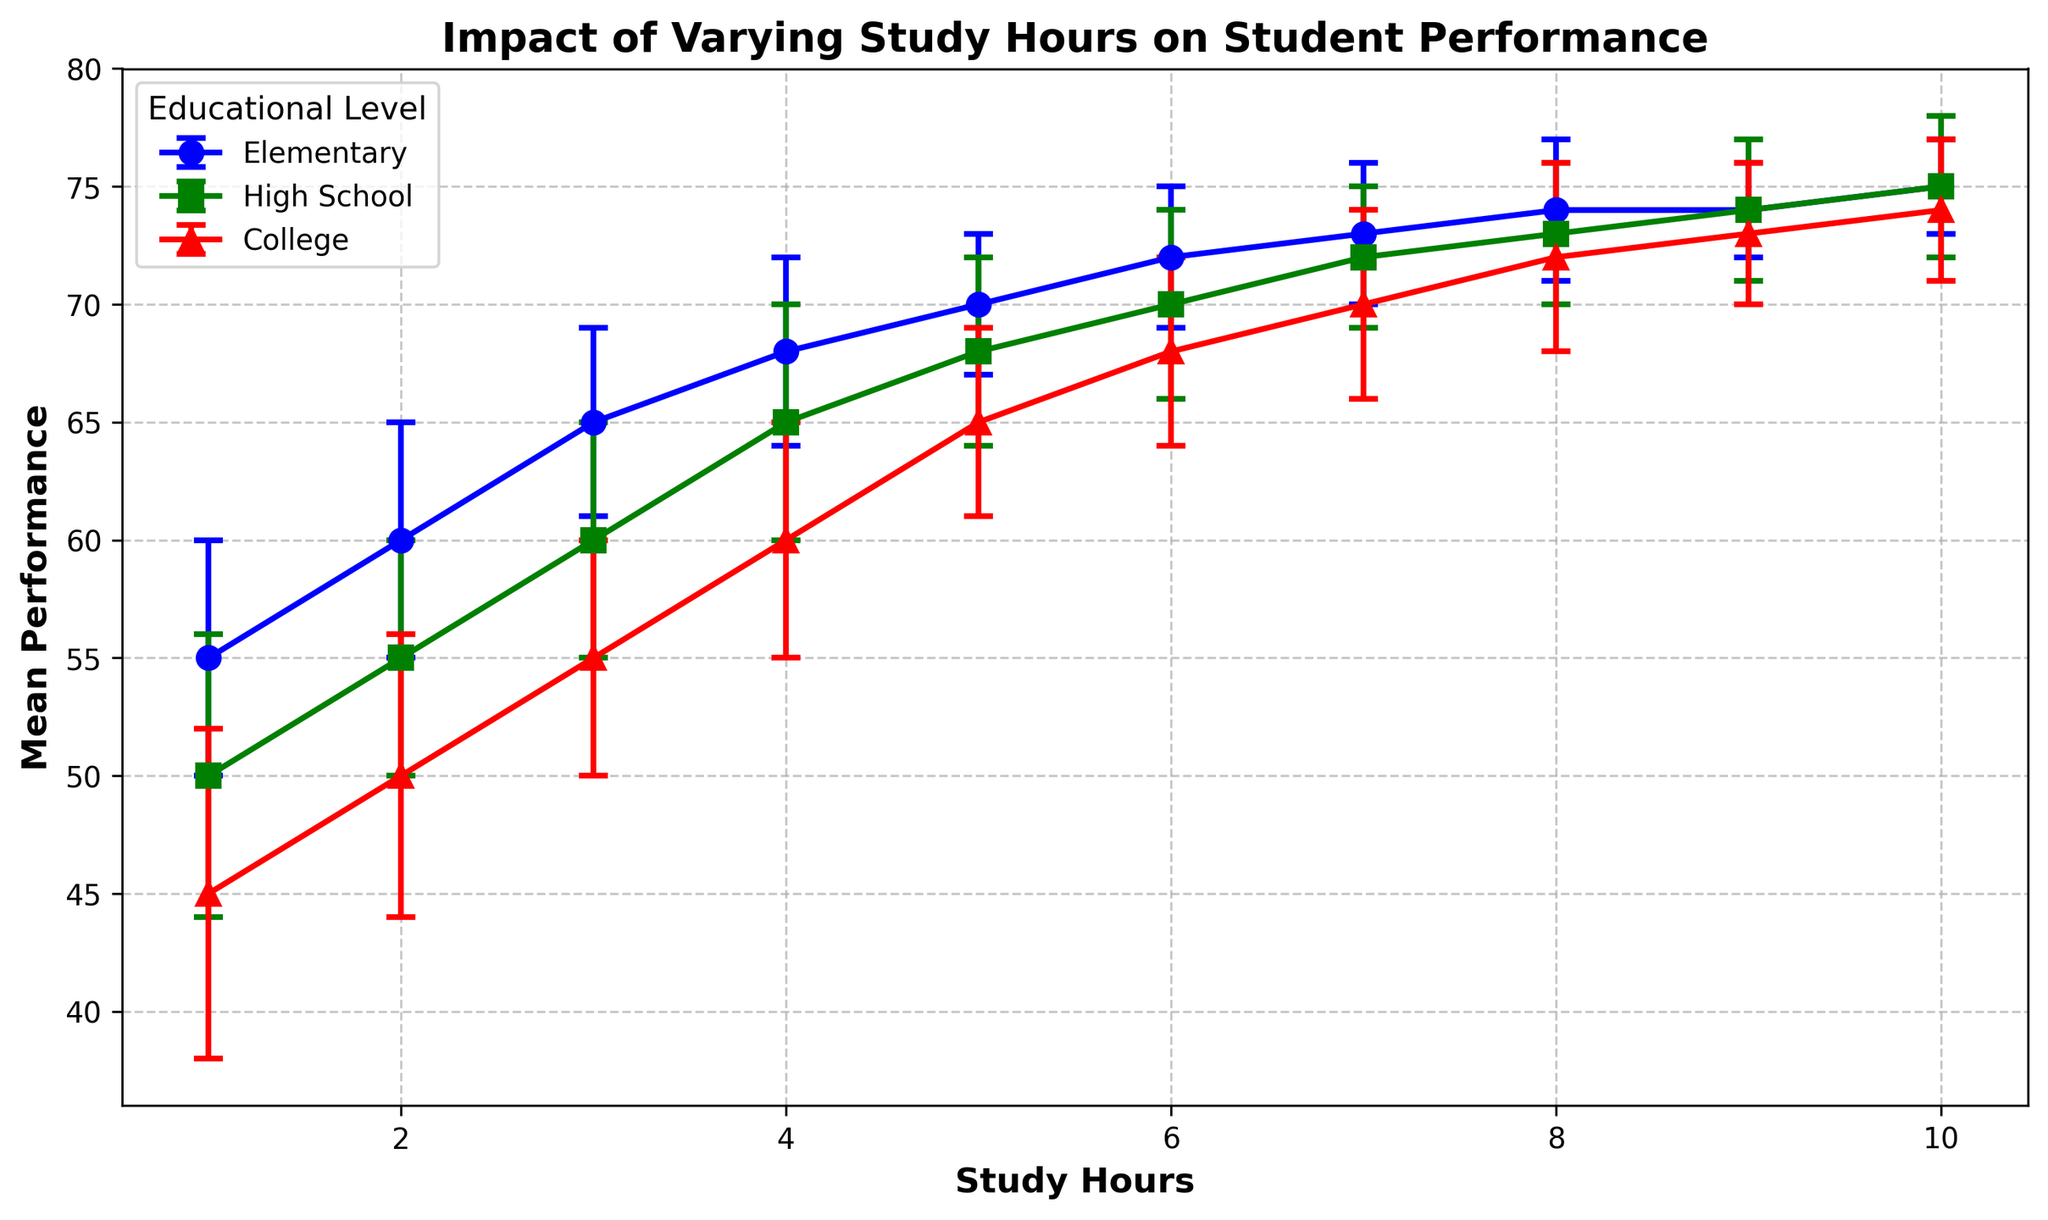How does the variability in performance among college students compare with elementary students across different study hours? To compare the variability in performance, look at the length of the error bars for each educational level. In general, college students show larger error bars (greater variability) than elementary students for the same number of study hours.
Answer: College students have larger variability Which educational level shows the smallest variability in performance at 10 study hours? To determine this, find the group with the shortest error bar at 10 study hours. The error bars for performance at 10 study hours are smallest for Elementary and High School, both with an error bar of ±2, while College has an error bar of ±3.
Answer: Elementary and High School At which study hour does high school performance exceed college performance by the largest margin? We need to look for the point where the difference in mean performance between high school and college is greatest. At 4 study hours, high school performance is 65 compared to college's 60, a difference of 5 points. This is the largest gap.
Answer: 4 hours Does the mean performance reach a plateau for any educational level as study hours increase? A plateau would be indicated by little to no increase in mean performance despite an increase in study hours. Across all educational levels, the performance appears to plateau around 9-10 study hours. For Elementary, High School, and College, the performances do not significantly increase after 8-9 study hours.
Answer: Yes, around 9-10 hours What is the difference in mean performance between elementary and high school students at 6 hours of study? The mean performance of elementary at 6 hours is 72, while for high school it is 70. The difference is found by subtracting the high school mean from the elementary mean: 72 - 70.
Answer: 2 points Which educational level shows the greatest improvement in mean performance from 1 to 10 study hours? To find this, calculate the difference in mean performance between 1 and 10 study hours for each level. 
Elementary: 75 - 55 = 20
High School: 75 - 50 = 25
College: 74 - 45 = 29
College shows the greatest improvement.
Answer: College At 7 study hours, which educational level has the tightest confidence interval for their performance? Tightest confidence interval corresponds to the smallest error bar. At 7 study hours, Elementary, High School, and College have error bars of ±3. All levels are the same in this case.
Answer: All levels How does the performance difference between elementary and high school students change from 2 to 8 study hours? Calculate the difference in performance at 2 study hours and 8 study hours.
2 hours: Elementary 60 - High School 55 = 5
8 hours: Elementary 74 - High School 73 = 1
The difference decreases by (5 - 1) = 4 points.
Answer: Decreases by 4 points In the 3-hour study category, which group has the highest performance and by how much more than the lowest performing group? The mean performances at 3 study hours are as follows: Elementary 65, High School 60, College 55. The highest performance is Elementary, and College is the lowest.
Difference = 65 - 55 = 10
Answer: Elementary; 10 points 